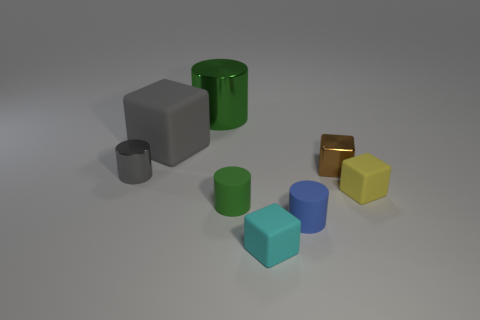There is a large thing that is the same color as the small shiny cylinder; what is its shape?
Make the answer very short. Cube. What is the material of the big green thing?
Give a very brief answer. Metal. Is the small yellow object made of the same material as the cyan thing?
Your answer should be compact. Yes. How many matte objects are small green cylinders or tiny yellow cubes?
Keep it short and to the point. 2. There is a small rubber thing left of the cyan thing; what is its shape?
Your answer should be compact. Cylinder. There is a green object that is the same material as the tiny blue cylinder; what is its size?
Give a very brief answer. Small. There is a small matte thing that is both to the left of the blue object and behind the tiny cyan cube; what shape is it?
Ensure brevity in your answer.  Cylinder. There is a matte block that is behind the yellow rubber cube; does it have the same color as the small metal cylinder?
Provide a short and direct response. Yes. Is the shape of the green thing behind the green rubber cylinder the same as the small metal object behind the tiny metallic cylinder?
Offer a very short reply. No. There is a rubber thing that is right of the blue object; what size is it?
Ensure brevity in your answer.  Small. 